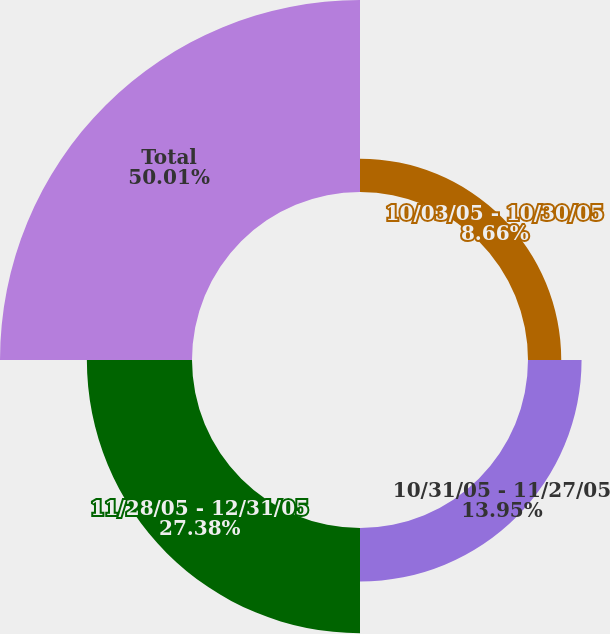Convert chart. <chart><loc_0><loc_0><loc_500><loc_500><pie_chart><fcel>10/03/05 - 10/30/05<fcel>10/31/05 - 11/27/05<fcel>11/28/05 - 12/31/05<fcel>Total<nl><fcel>8.66%<fcel>13.95%<fcel>27.38%<fcel>50.0%<nl></chart> 